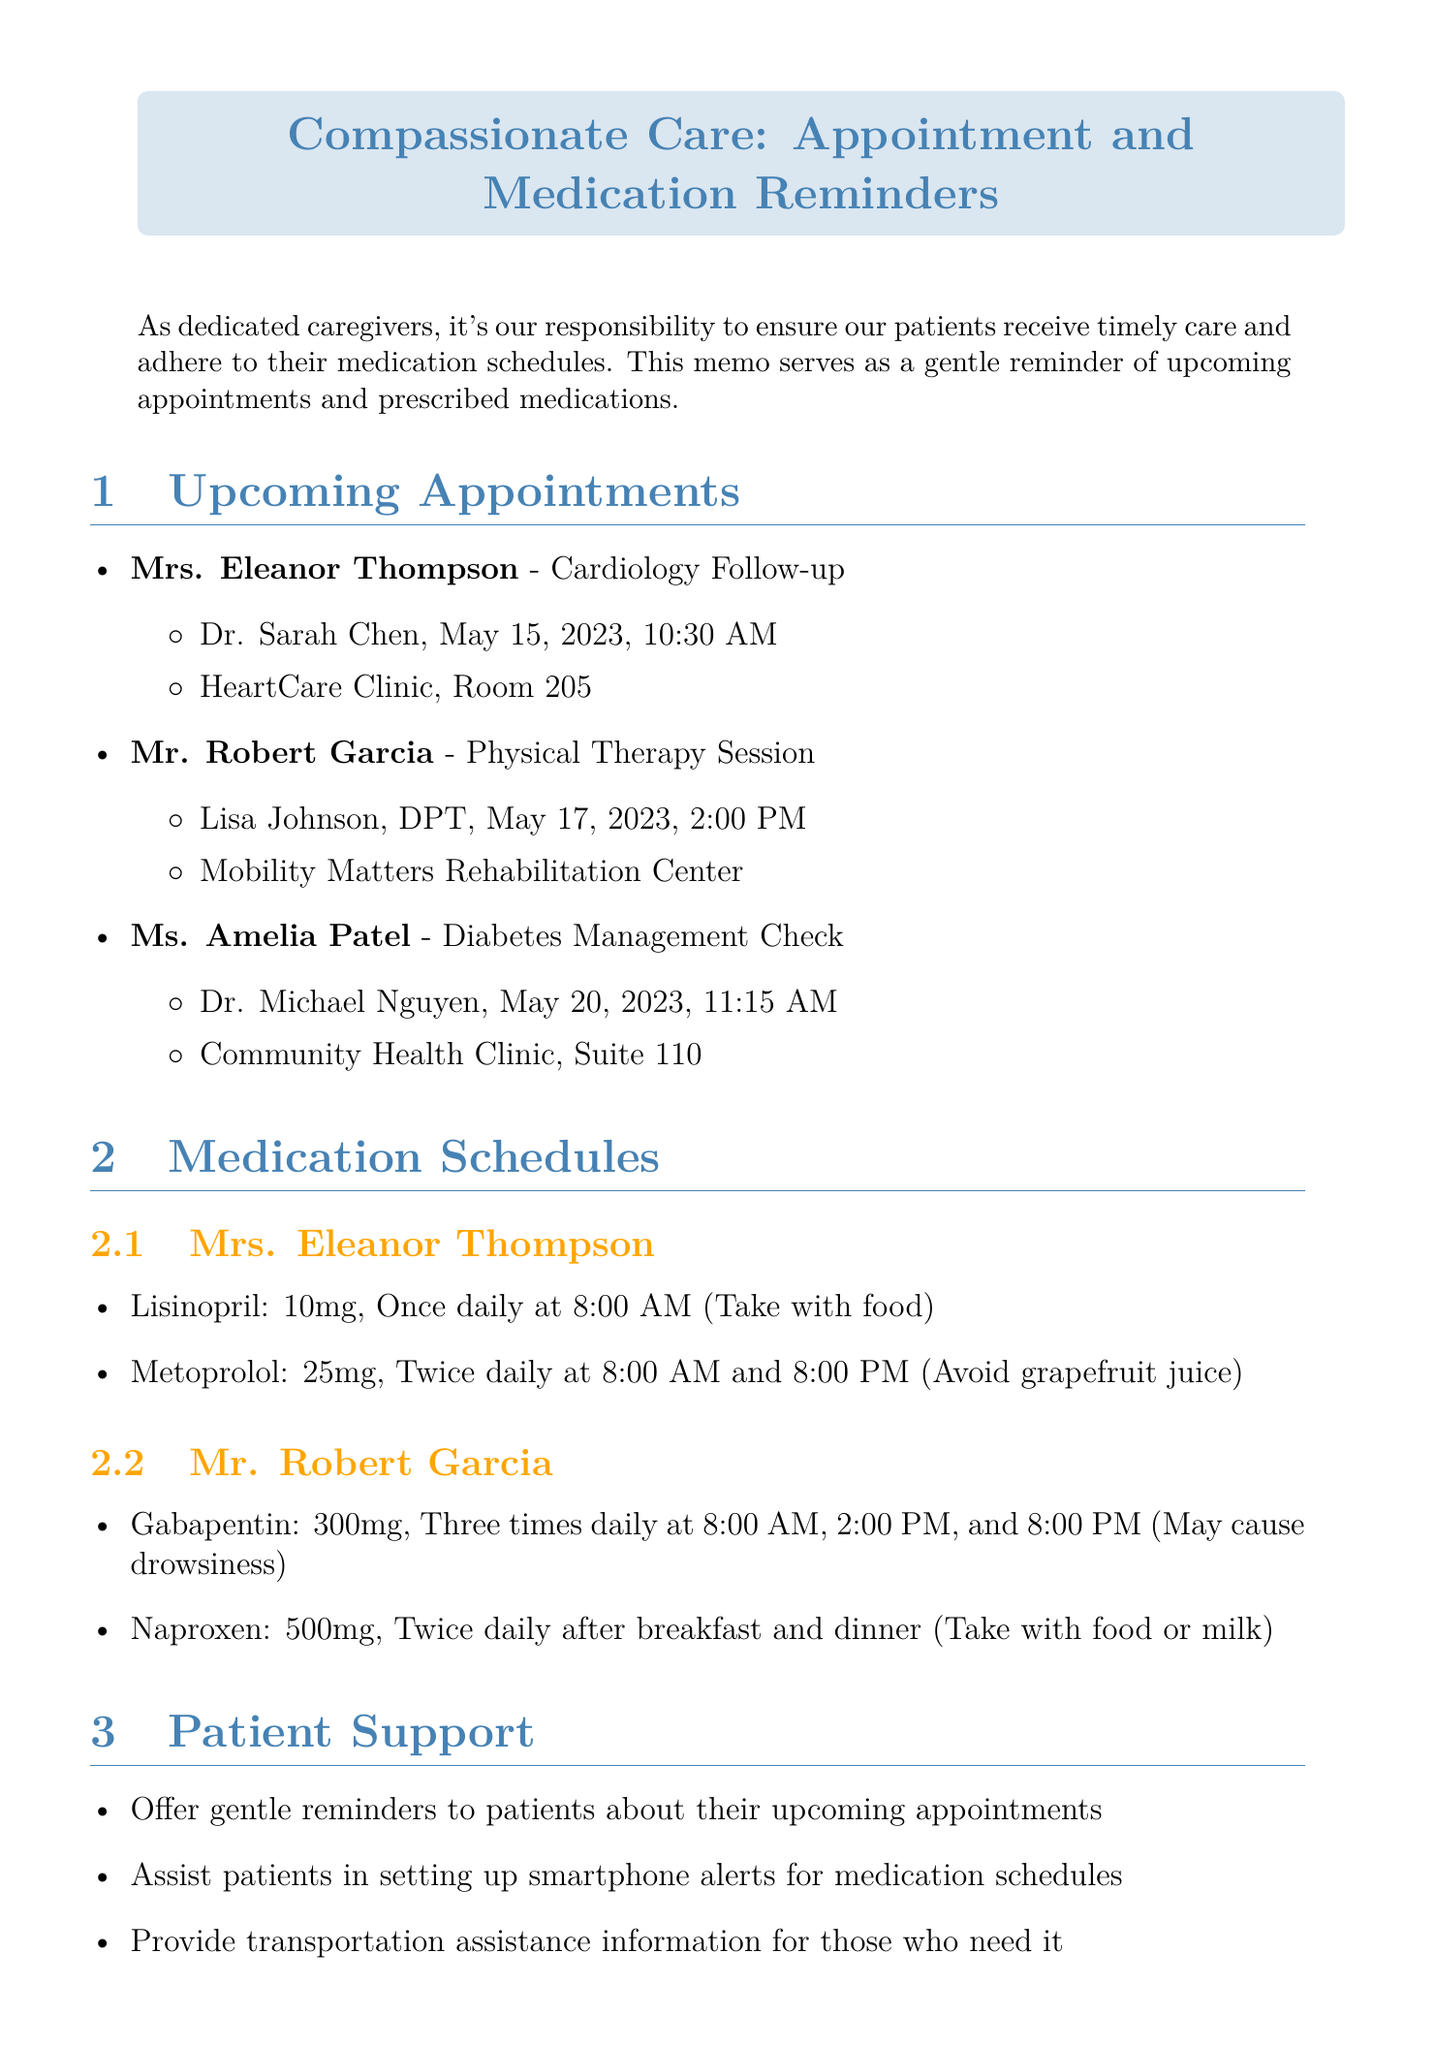What is the appointment type for Mrs. Eleanor Thompson? The appointment type is listed specifically under her details in the document.
Answer: Cardiology Follow-up When is Mr. Robert Garcia's physical therapy session? The date and time for Mr. Garcia's session are provided in the upcoming appointments section.
Answer: May 17, 2023, 2:00 PM What medication is prescribed to Mrs. Eleanor Thompson at 8:00 AM? The document lists the medications and their specified times for administration.
Answer: Lisinopril How many times a day should Mr. Garcia take Gabapentin? This information is directly mentioned in the medication schedules section of the document.
Answer: Three times daily What special instruction is given for Metoprolol? This is included in the medication details provided for Mrs. Eleanor Thompson.
Answer: Avoid grapefruit juice What is the role of caregivers as mentioned in the conclusion? The conclusion outlines the responsibilities of caregivers from the provided document.
Answer: Compassionate care Which clinic is Ms. Amelia Patel’s diabetes check appointment scheduled at? The location for Ms. Patel's appointment is specified in the upcoming appointments section.
Answer: Community Health Clinic, Suite 110 What support can be offered to patients before their appointments? The document lists specific patient support actions that caregivers can take.
Answer: Gentle reminders to patients about their upcoming appointments How often should medication dosages and timing be double-checked? This is a caregiver reminder that emphasizes the importance of accuracy in medication administration.
Answer: Before administration Who is the doctor for Mrs. Eleanor Thompson’s follow-up appointment? The name of the doctor is specifically mentioned in the details of Mrs. Thompson's appointment.
Answer: Dr. Sarah Chen 